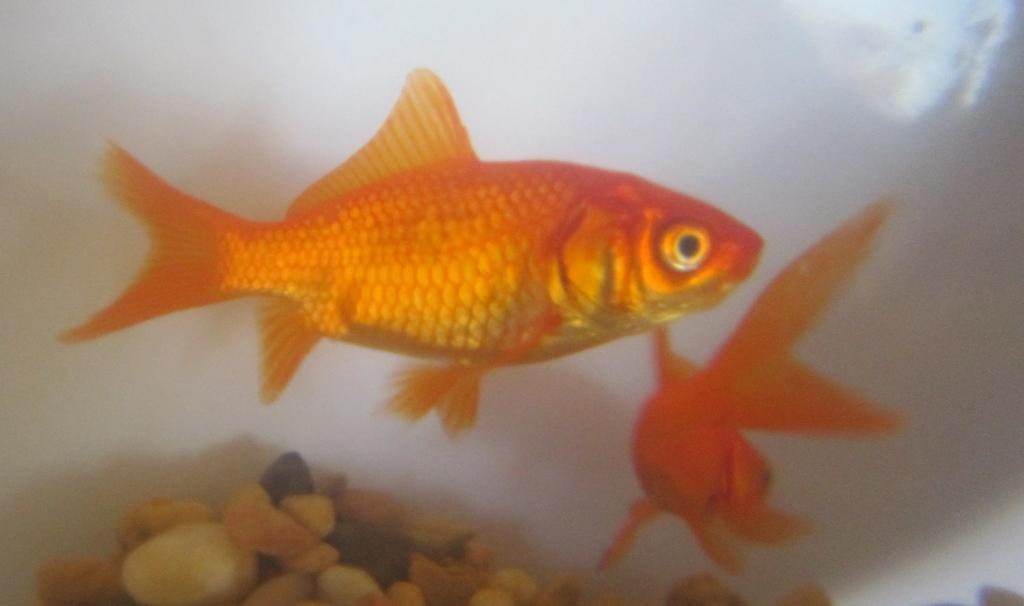What animals are present in the image? There are two goldfish in the image. What are the goldfish doing in the image? The goldfish are moving in the water. What else can be seen in the image besides the goldfish? There are rocks in the image. What type of hen can be seen laying eggs on the rocks in the image? There is no hen or eggs present in the image; it features two goldfish moving in the water and rocks. Can you tell me how many beans are scattered among the rocks in the image? There are no beans present in the image; it only features goldfish and rocks. 